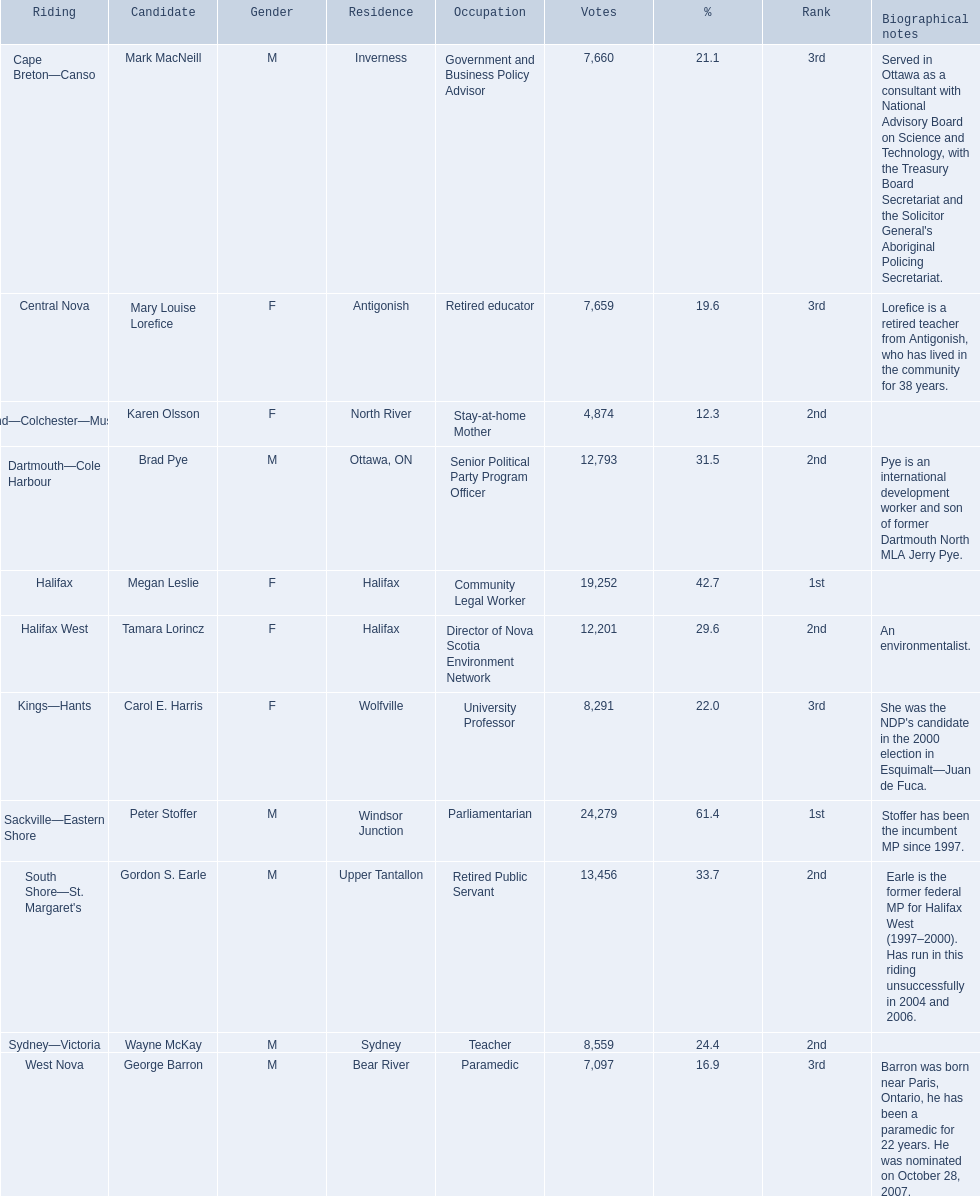Which individuals from the new democratic party participated in the 2008 canadian federal election? Mark MacNeill, Mary Louise Lorefice, Karen Olsson, Brad Pye, Megan Leslie, Tamara Lorincz, Carol E. Harris, Peter Stoffer, Gordon S. Earle, Wayne McKay, George Barron. Among them, who were the female candidates? Mary Louise Lorefice, Karen Olsson, Megan Leslie, Tamara Lorincz, Carol E. Harris. Which one of these candidates lived in halifax? Megan Leslie, Tamara Lorincz. Out of the last two, who secured the 1st position? Megan Leslie. What was her vote count? 19,252. 